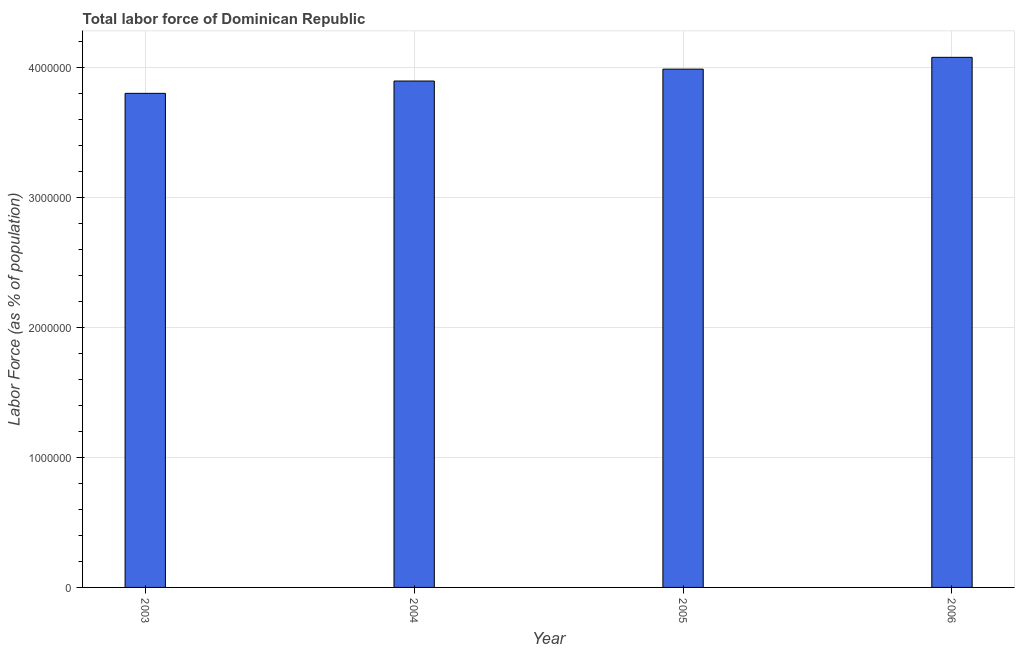Does the graph contain grids?
Your response must be concise. Yes. What is the title of the graph?
Give a very brief answer. Total labor force of Dominican Republic. What is the label or title of the X-axis?
Provide a short and direct response. Year. What is the label or title of the Y-axis?
Provide a short and direct response. Labor Force (as % of population). What is the total labor force in 2005?
Your response must be concise. 3.99e+06. Across all years, what is the maximum total labor force?
Offer a very short reply. 4.08e+06. Across all years, what is the minimum total labor force?
Your answer should be compact. 3.80e+06. What is the sum of the total labor force?
Provide a short and direct response. 1.58e+07. What is the difference between the total labor force in 2003 and 2004?
Keep it short and to the point. -9.49e+04. What is the average total labor force per year?
Provide a succinct answer. 3.94e+06. What is the median total labor force?
Ensure brevity in your answer.  3.94e+06. In how many years, is the total labor force greater than 3600000 %?
Offer a terse response. 4. Do a majority of the years between 2006 and 2004 (inclusive) have total labor force greater than 2400000 %?
Your answer should be compact. Yes. What is the ratio of the total labor force in 2004 to that in 2005?
Your answer should be compact. 0.98. What is the difference between the highest and the second highest total labor force?
Keep it short and to the point. 9.09e+04. Is the sum of the total labor force in 2003 and 2005 greater than the maximum total labor force across all years?
Your answer should be compact. Yes. What is the difference between the highest and the lowest total labor force?
Your answer should be compact. 2.77e+05. How many bars are there?
Your response must be concise. 4. How many years are there in the graph?
Your answer should be very brief. 4. What is the difference between two consecutive major ticks on the Y-axis?
Ensure brevity in your answer.  1.00e+06. Are the values on the major ticks of Y-axis written in scientific E-notation?
Your response must be concise. No. What is the Labor Force (as % of population) in 2003?
Make the answer very short. 3.80e+06. What is the Labor Force (as % of population) in 2004?
Keep it short and to the point. 3.90e+06. What is the Labor Force (as % of population) in 2005?
Offer a very short reply. 3.99e+06. What is the Labor Force (as % of population) in 2006?
Ensure brevity in your answer.  4.08e+06. What is the difference between the Labor Force (as % of population) in 2003 and 2004?
Provide a short and direct response. -9.49e+04. What is the difference between the Labor Force (as % of population) in 2003 and 2005?
Make the answer very short. -1.86e+05. What is the difference between the Labor Force (as % of population) in 2003 and 2006?
Offer a very short reply. -2.77e+05. What is the difference between the Labor Force (as % of population) in 2004 and 2005?
Your answer should be very brief. -9.15e+04. What is the difference between the Labor Force (as % of population) in 2004 and 2006?
Your response must be concise. -1.82e+05. What is the difference between the Labor Force (as % of population) in 2005 and 2006?
Give a very brief answer. -9.09e+04. What is the ratio of the Labor Force (as % of population) in 2003 to that in 2005?
Ensure brevity in your answer.  0.95. What is the ratio of the Labor Force (as % of population) in 2003 to that in 2006?
Your response must be concise. 0.93. What is the ratio of the Labor Force (as % of population) in 2004 to that in 2006?
Your response must be concise. 0.95. 